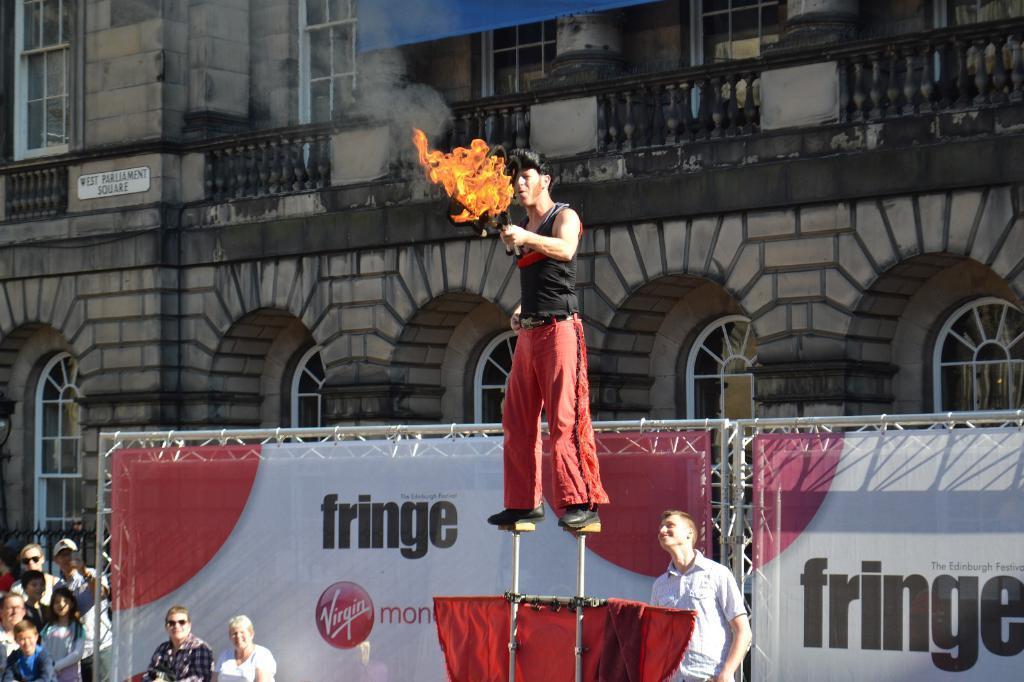Please provide a concise description of this image. In this picture there is a man in the center of the image, by holding fire object in his hand, he is walking on the roads, there are people at the bottom side of the image and there is a poster at the bottom side of the image, there is a huge building in the background area of the image. 